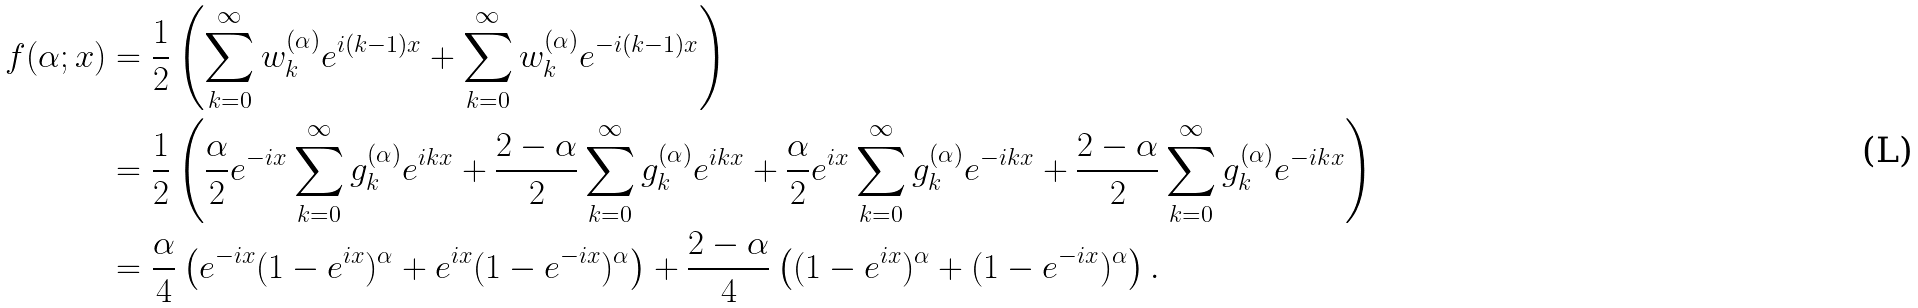Convert formula to latex. <formula><loc_0><loc_0><loc_500><loc_500>f ( \alpha ; x ) & = \frac { 1 } { 2 } \left ( \sum _ { k = 0 } ^ { \infty } w _ { k } ^ { ( \alpha ) } e ^ { i ( k - 1 ) x } + \sum _ { k = 0 } ^ { \infty } w _ { k } ^ { ( \alpha ) } e ^ { - i ( k - 1 ) x } \right ) \\ & = \frac { 1 } { 2 } \left ( \frac { \alpha } { 2 } e ^ { - i x } \sum _ { k = 0 } ^ { \infty } g _ { k } ^ { ( \alpha ) } e ^ { i k x } + \frac { 2 - \alpha } { 2 } \sum _ { k = 0 } ^ { \infty } g _ { k } ^ { ( \alpha ) } e ^ { i k x } + \frac { \alpha } { 2 } e ^ { i x } \sum _ { k = 0 } ^ { \infty } g _ { k } ^ { ( \alpha ) } e ^ { - i k x } + \frac { 2 - \alpha } { 2 } \sum _ { k = 0 } ^ { \infty } g _ { k } ^ { ( \alpha ) } e ^ { - i k x } \right ) \\ & = \frac { \alpha } { 4 } \left ( e ^ { - i x } ( 1 - e ^ { i x } ) ^ { \alpha } + e ^ { i x } ( 1 - e ^ { - i x } ) ^ { \alpha } \right ) + \frac { 2 - \alpha } { 4 } \left ( ( 1 - e ^ { i x } ) ^ { \alpha } + ( 1 - e ^ { - i x } ) ^ { \alpha } \right ) .</formula> 